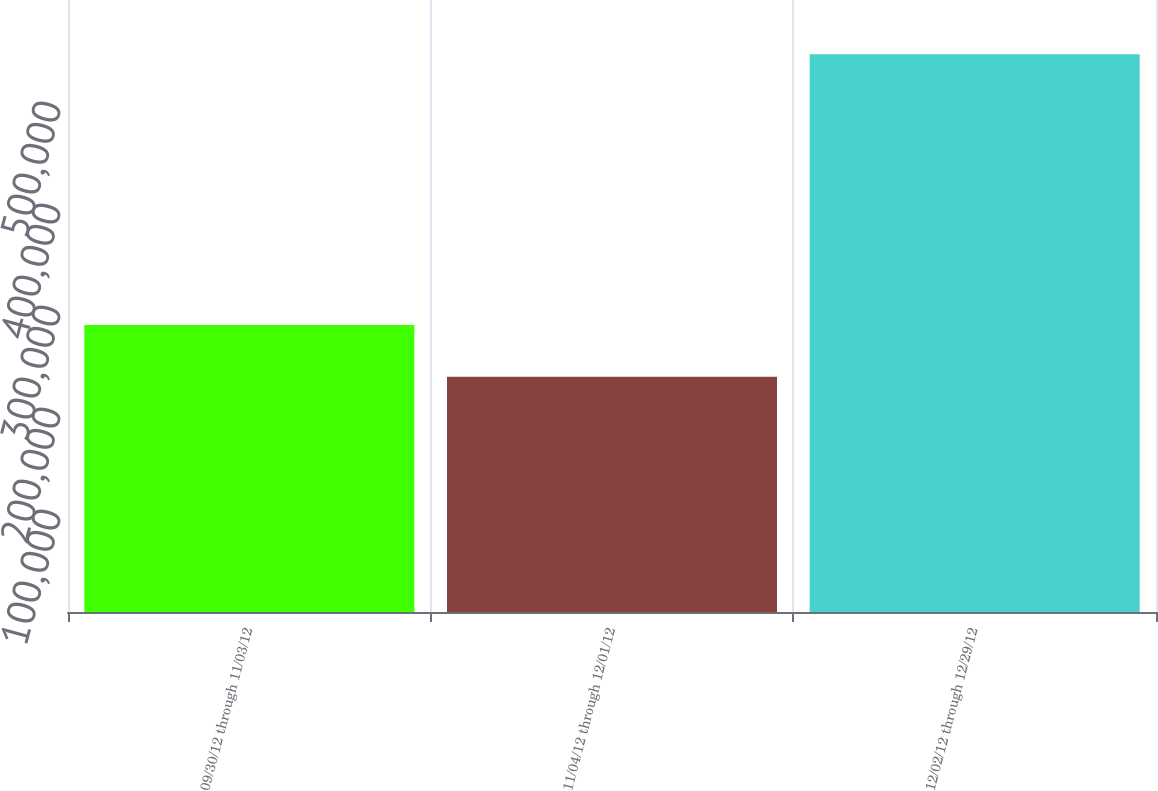Convert chart. <chart><loc_0><loc_0><loc_500><loc_500><bar_chart><fcel>09/30/12 through 11/03/12<fcel>11/04/12 through 12/01/12<fcel>12/02/12 through 12/29/12<nl><fcel>281428<fcel>230700<fcel>546899<nl></chart> 